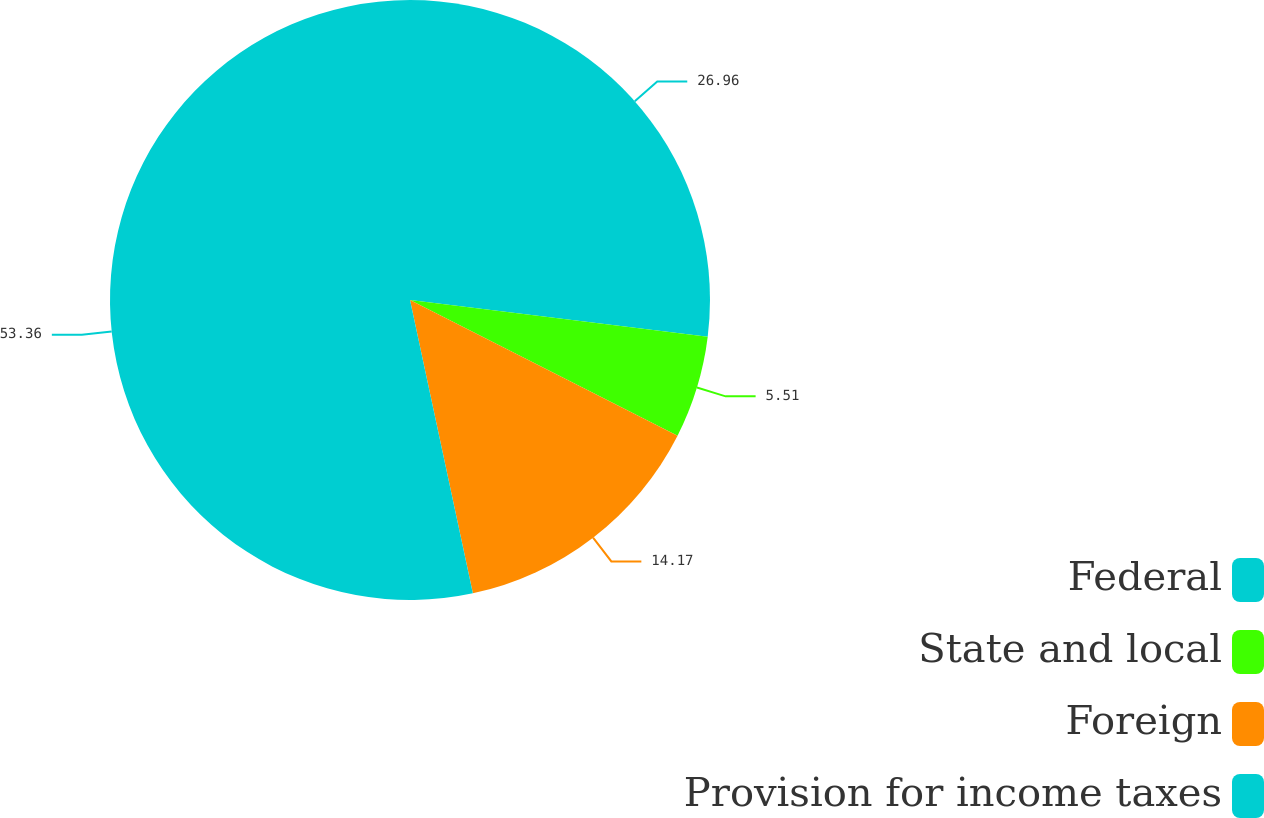<chart> <loc_0><loc_0><loc_500><loc_500><pie_chart><fcel>Federal<fcel>State and local<fcel>Foreign<fcel>Provision for income taxes<nl><fcel>26.96%<fcel>5.51%<fcel>14.17%<fcel>53.36%<nl></chart> 